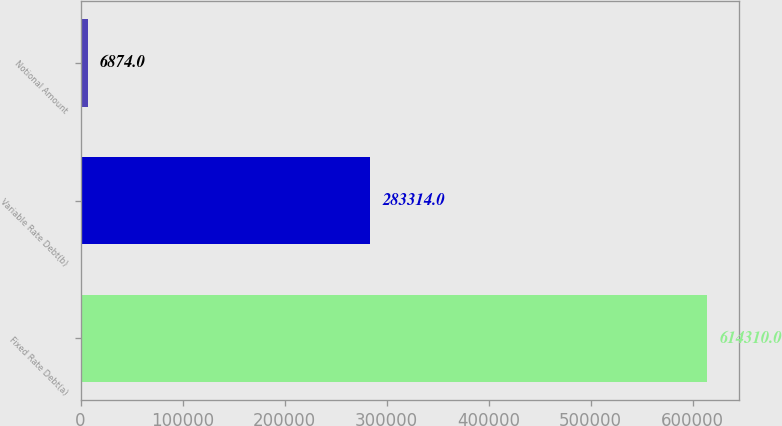<chart> <loc_0><loc_0><loc_500><loc_500><bar_chart><fcel>Fixed Rate Debt(a)<fcel>Variable Rate Debt(b)<fcel>Notional Amount<nl><fcel>614310<fcel>283314<fcel>6874<nl></chart> 